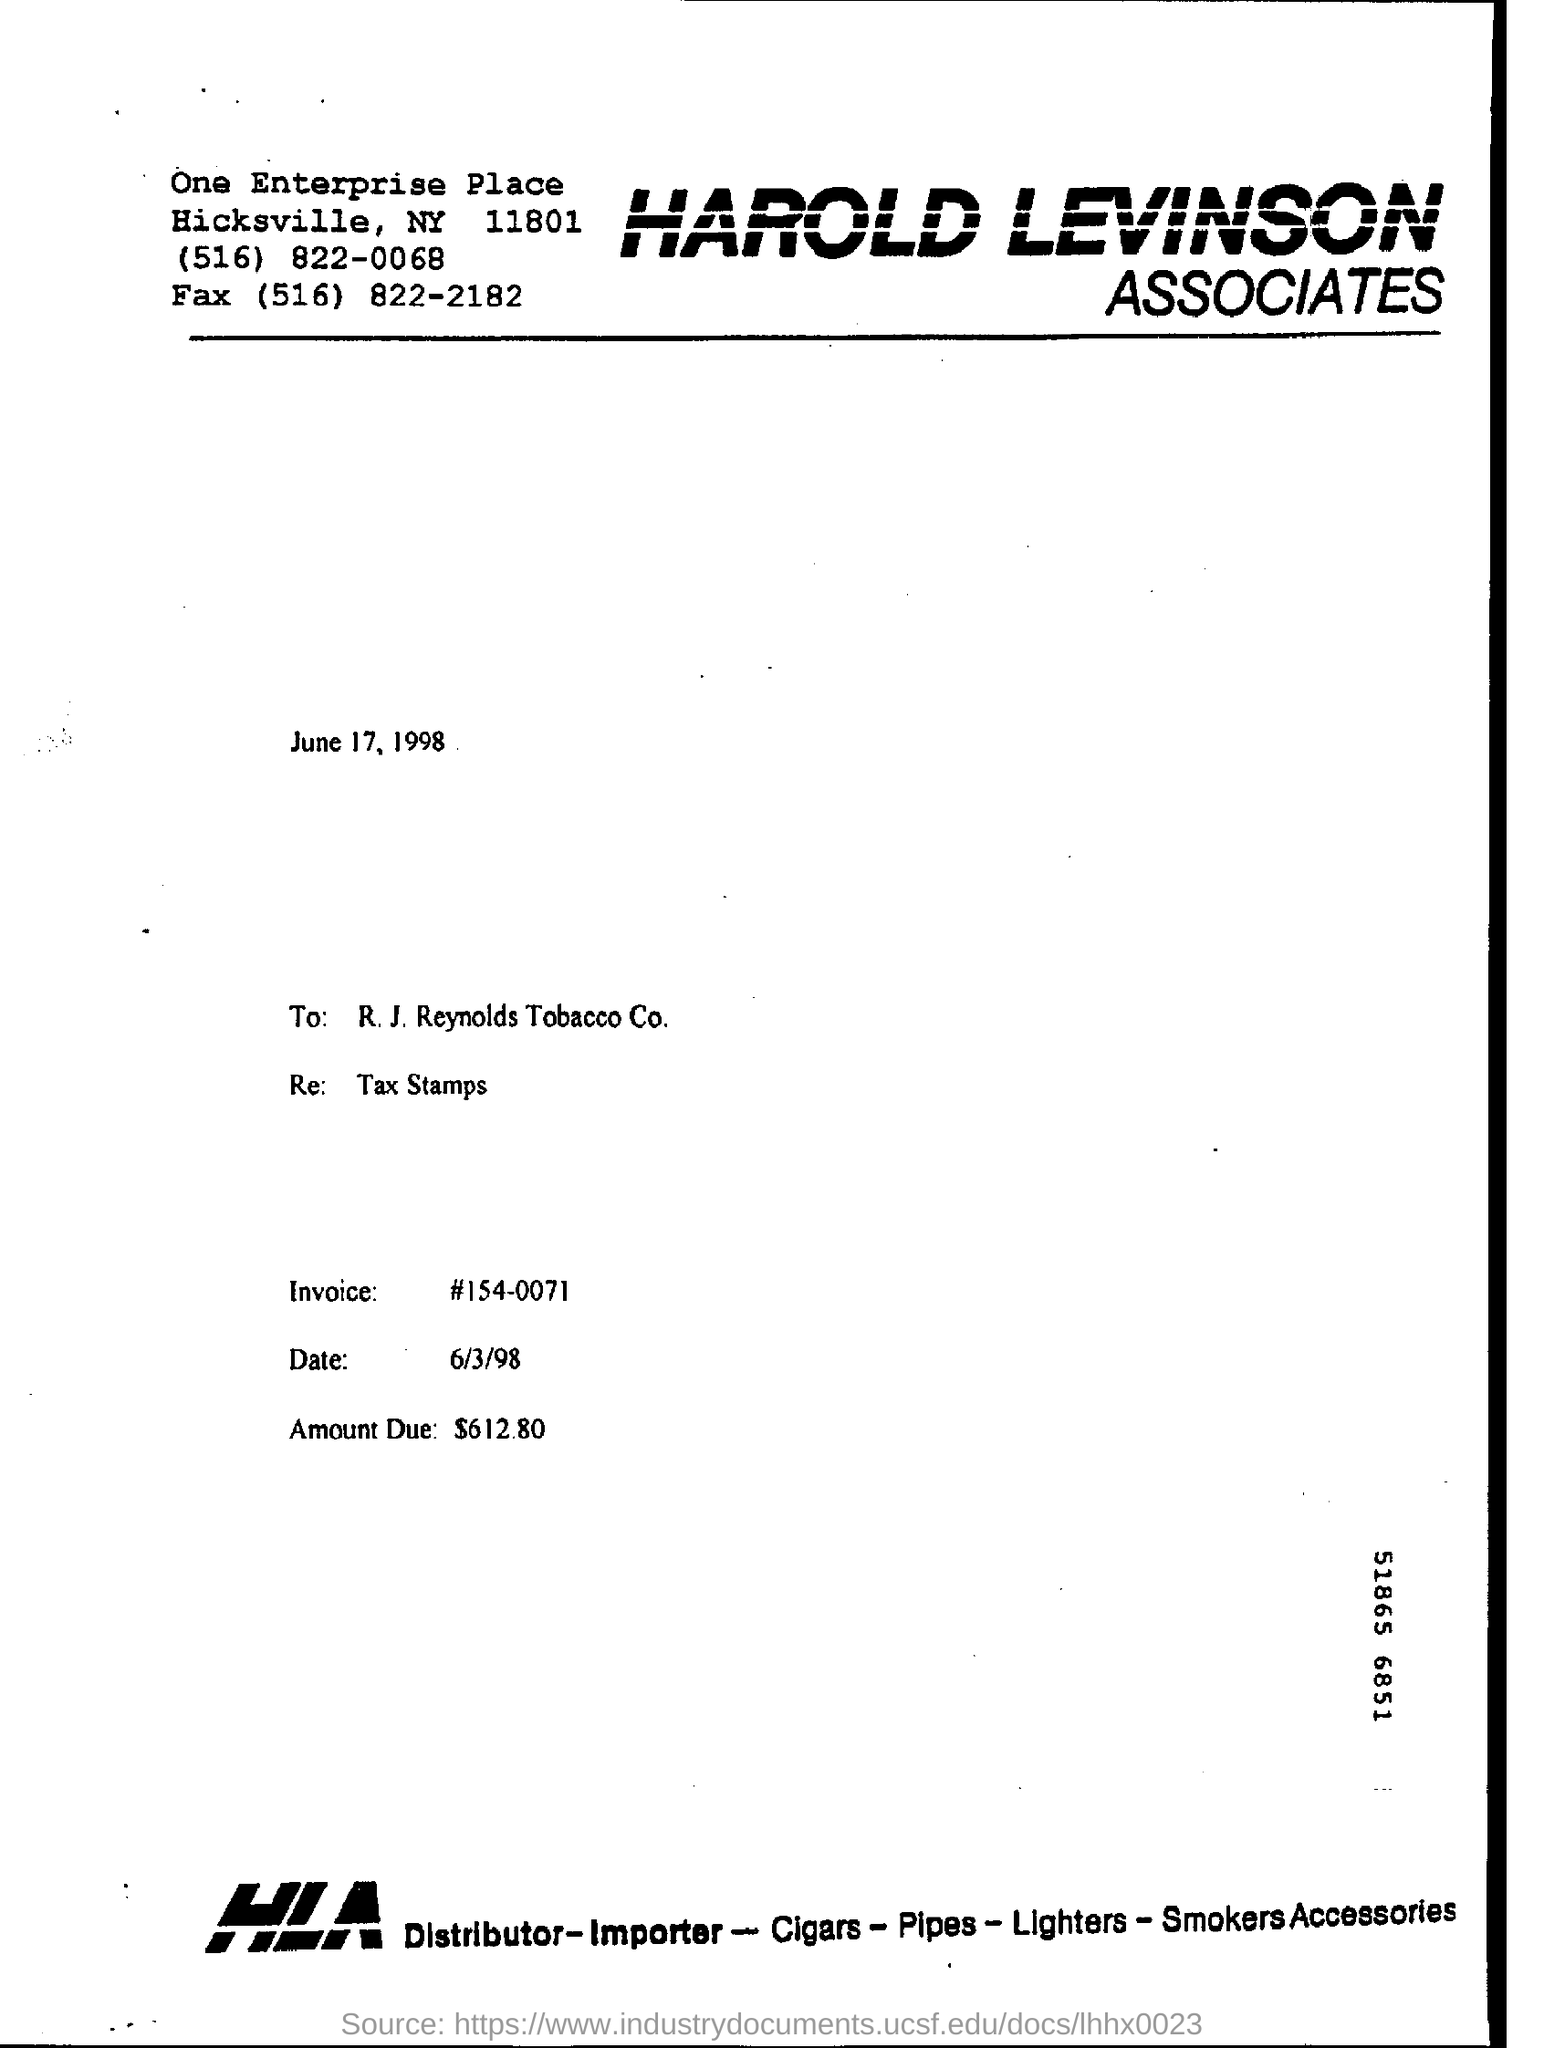What is the invoice number?
Your answer should be very brief. 154-0071. What is the due amount?
Keep it short and to the point. $612.80. 